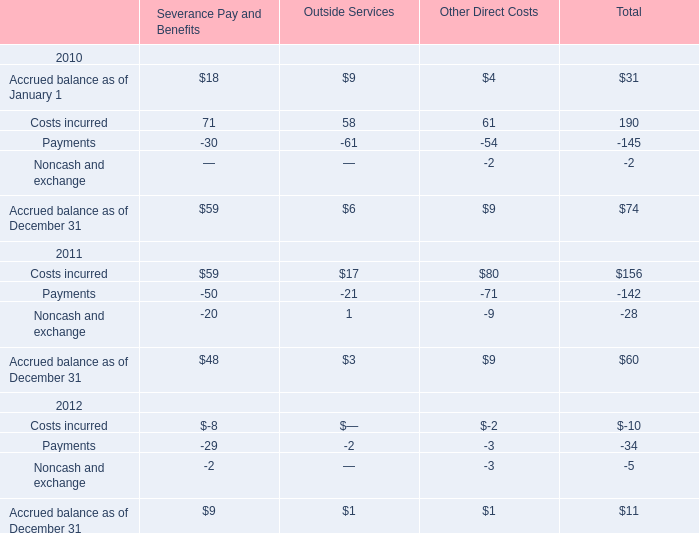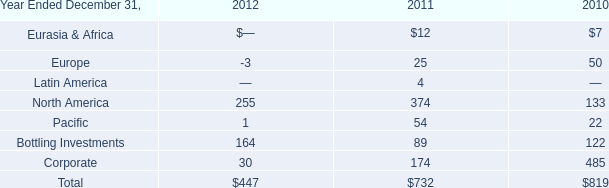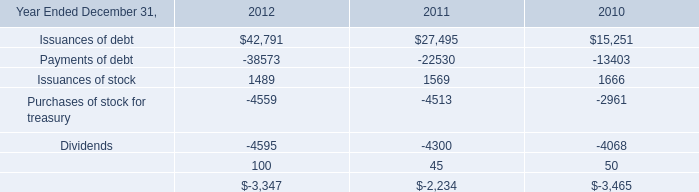What was the total amount of the Payments in the years where Costs incurred for Total is greater than 160? 
Computations: ((-30 - 61) - 54)
Answer: -145.0. 